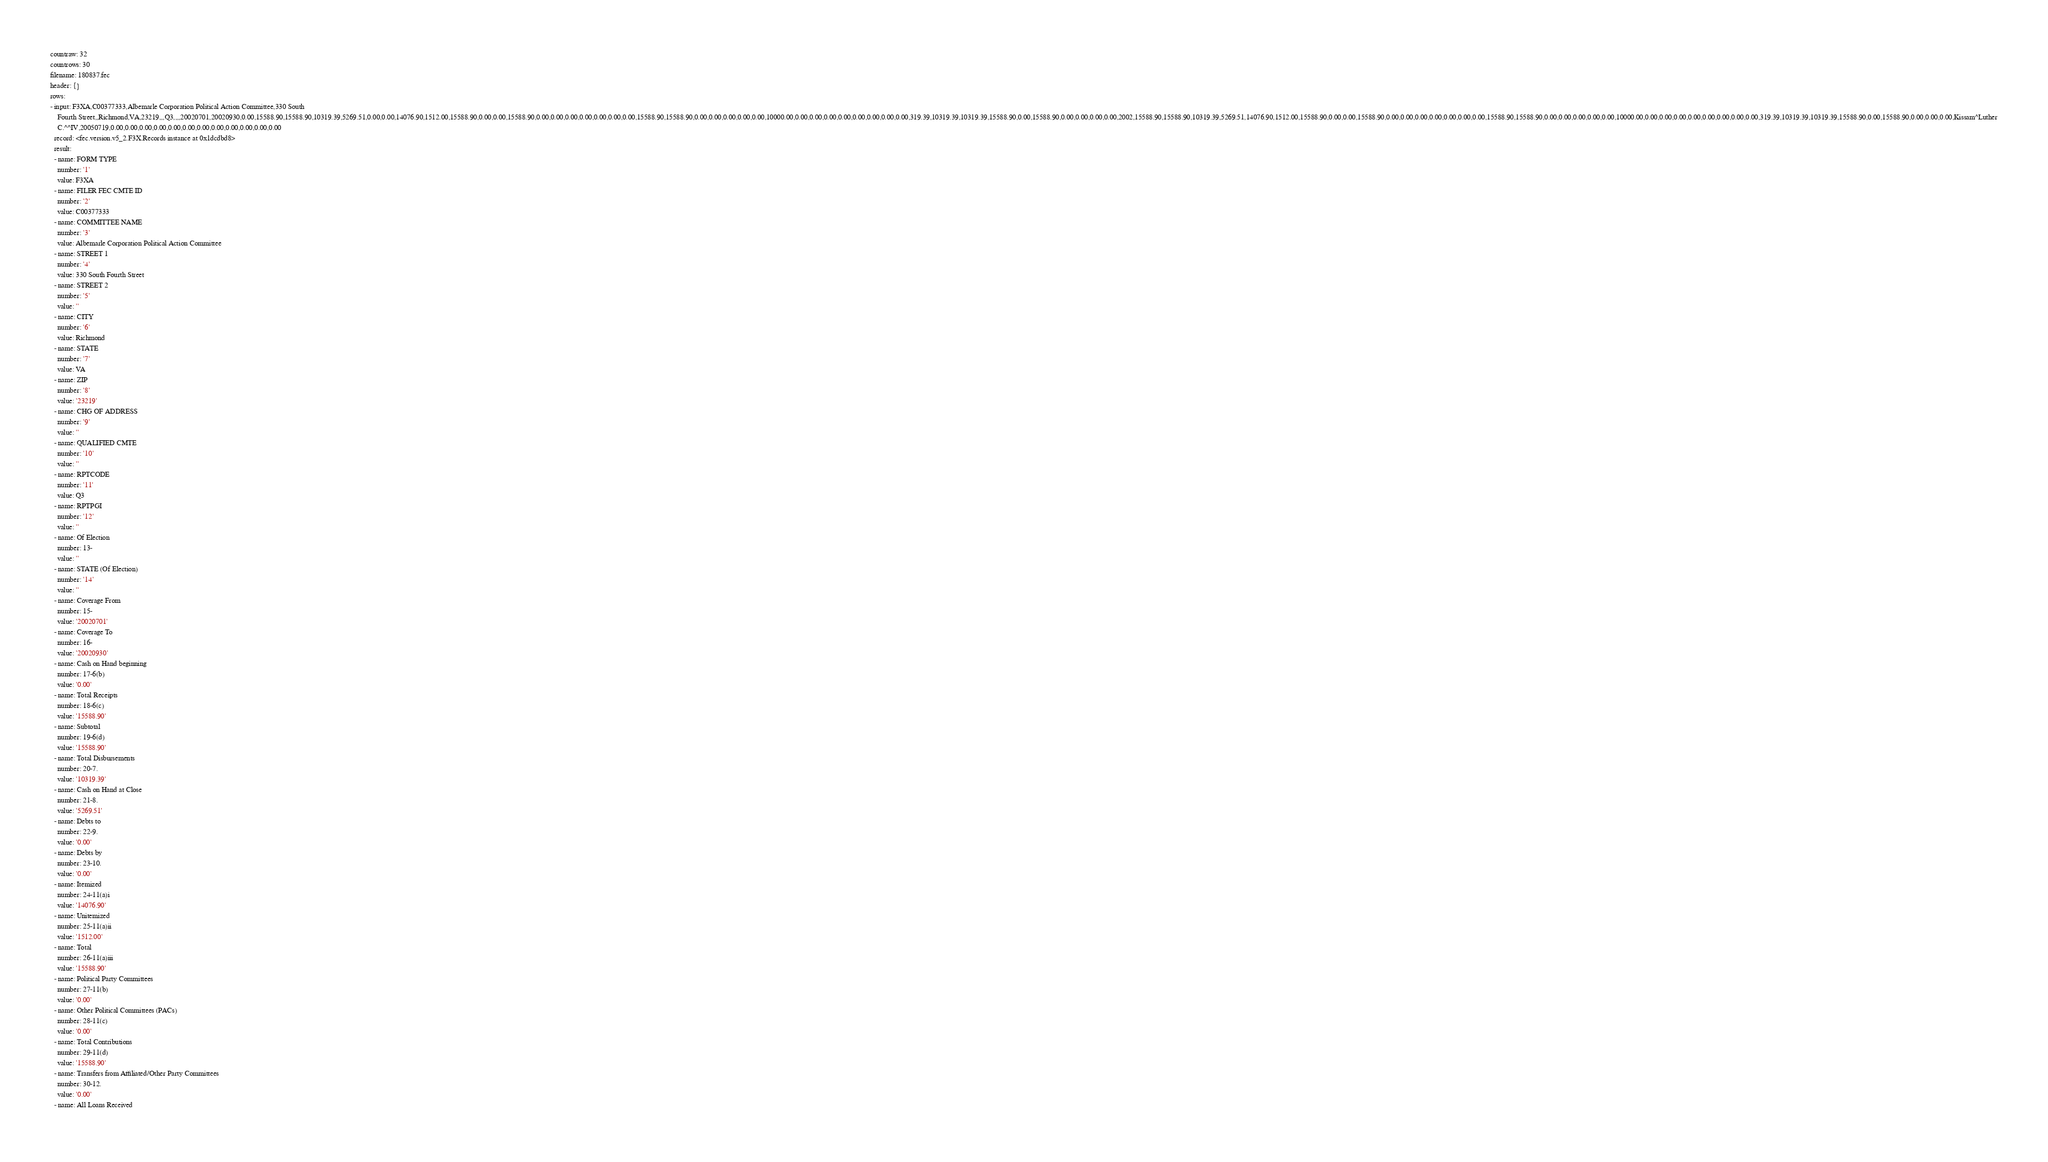Convert code to text. <code><loc_0><loc_0><loc_500><loc_500><_YAML_>countraw: 32
countrows: 30
filename: 180837.fec
header: {}
rows:
- input: F3XA,C00377333,Albemarle Corporation Political Action Committee,330 South
    Fourth Street,,Richmond,VA,23219,,,Q3,,,,20020701,20020930,0.00,15588.90,15588.90,10319.39,5269.51,0.00,0.00,14076.90,1512.00,15588.90,0.00,0.00,15588.90,0.00,0.00,0.00,0.00,0.00,0.00,0.00,15588.90,15588.90,0.00,0.00,0.00,0.00,0.00,10000.00,0.00,0.00,0.00,0.00,0.00,0.00,0.00,0.00,319.39,10319.39,10319.39,15588.90,0.00,15588.90,0.00,0.00,0.00,0.00,2002,15588.90,15588.90,10319.39,5269.51,14076.90,1512.00,15588.90,0.00,0.00,15588.90,0.00,0.00,0.00,0.00,0.00,0.00,0.00,15588.90,15588.90,0.00,0.00,0.00,0.00,0.00,10000.00,0.00,0.00,0.00,0.00,0.00,0.00,0.00,0.00,319.39,10319.39,10319.39,15588.90,0.00,15588.90,0.00,0.00,0.00,Kissam^Luther
    C.^^IV,20050719,0.00,0.00,0.00,0.00,0.00,0.00,0.00,0.00,0.00,0.00,0.00,0.00
  record: <fec.version.v5_2.F3X.Records instance at 0x1dcdbd8>
  result:
  - name: FORM TYPE
    number: '1'
    value: F3XA
  - name: FILER FEC CMTE ID
    number: '2'
    value: C00377333
  - name: COMMITTEE NAME
    number: '3'
    value: Albemarle Corporation Political Action Committee
  - name: STREET 1
    number: '4'
    value: 330 South Fourth Street
  - name: STREET 2
    number: '5'
    value: ''
  - name: CITY
    number: '6'
    value: Richmond
  - name: STATE
    number: '7'
    value: VA
  - name: ZIP
    number: '8'
    value: '23219'
  - name: CHG OF ADDRESS
    number: '9'
    value: ''
  - name: QUALIFIED CMTE
    number: '10'
    value: ''
  - name: RPTCODE
    number: '11'
    value: Q3
  - name: RPTPGI
    number: '12'
    value: ''
  - name: Of Election
    number: 13-
    value: ''
  - name: STATE (Of Election)
    number: '14'
    value: ''
  - name: Coverage From
    number: 15-
    value: '20020701'
  - name: Coverage To
    number: 16-
    value: '20020930'
  - name: Cash on Hand beginning
    number: 17-6(b)
    value: '0.00'
  - name: Total Receipts
    number: 18-6(c)
    value: '15588.90'
  - name: Subtotal
    number: 19-6(d)
    value: '15588.90'
  - name: Total Disbursements
    number: 20-7.
    value: '10319.39'
  - name: Cash on Hand at Close
    number: 21-8.
    value: '5269.51'
  - name: Debts to
    number: 22-9.
    value: '0.00'
  - name: Debts by
    number: 23-10.
    value: '0.00'
  - name: Itemized
    number: 24-11(a)i
    value: '14076.90'
  - name: Unitemized
    number: 25-11(a)ii
    value: '1512.00'
  - name: Total
    number: 26-11(a)iii
    value: '15588.90'
  - name: Political Party Committees
    number: 27-11(b)
    value: '0.00'
  - name: Other Political Committees (PACs)
    number: 28-11(c)
    value: '0.00'
  - name: Total Contributions
    number: 29-11(d)
    value: '15588.90'
  - name: Transfers from Affiliated/Other Party Committees
    number: 30-12.
    value: '0.00'
  - name: All Loans Received</code> 